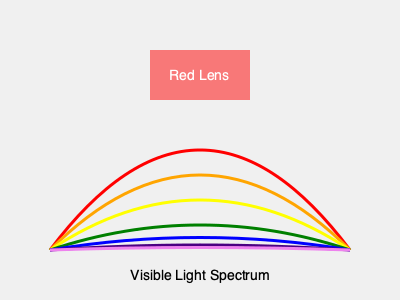If you wear red contact lenses as shown in the diagram, which color in the visible light spectrum would appear brightest, and why? To understand how red contact lenses affect color perception, we need to consider the following steps:

1. The visible light spectrum consists of different wavelengths of light, ranging from red (longest wavelength) to violet (shortest wavelength).

2. Red contact lenses act as a filter, allowing red light to pass through while absorbing or blocking other colors.

3. When light passes through a red lens:
   a. Red light is transmitted almost entirely.
   b. Orange and yellow light are partially transmitted.
   c. Green, blue, indigo, and violet light are mostly absorbed.

4. The human eye perceives brightness based on the amount of light that reaches the retina.

5. Since red light passes through the red lens with the least absorption, it will appear brightest to the wearer.

6. Other colors will appear darker or less vibrant due to partial or complete absorption by the red lens.

Therefore, when wearing red contact lenses, the red portion of the visible light spectrum will appear brightest because it is the least affected by the filtering properties of the lens.
Answer: Red 